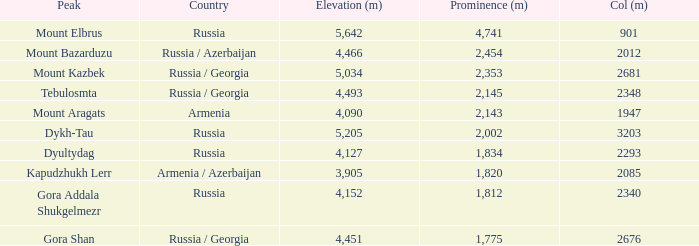What is the Elevation (m) of the Peak with a Prominence (m) larger than 2,143 and Col (m) of 2012? 4466.0. 